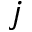<formula> <loc_0><loc_0><loc_500><loc_500>j</formula> 